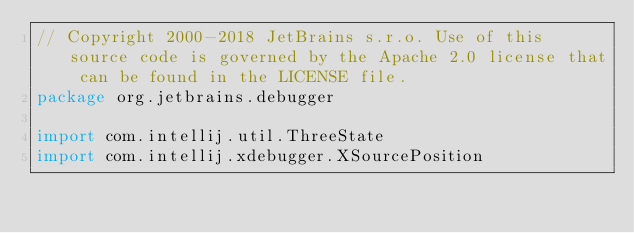Convert code to text. <code><loc_0><loc_0><loc_500><loc_500><_Kotlin_>// Copyright 2000-2018 JetBrains s.r.o. Use of this source code is governed by the Apache 2.0 license that can be found in the LICENSE file.
package org.jetbrains.debugger

import com.intellij.util.ThreeState
import com.intellij.xdebugger.XSourcePosition</code> 